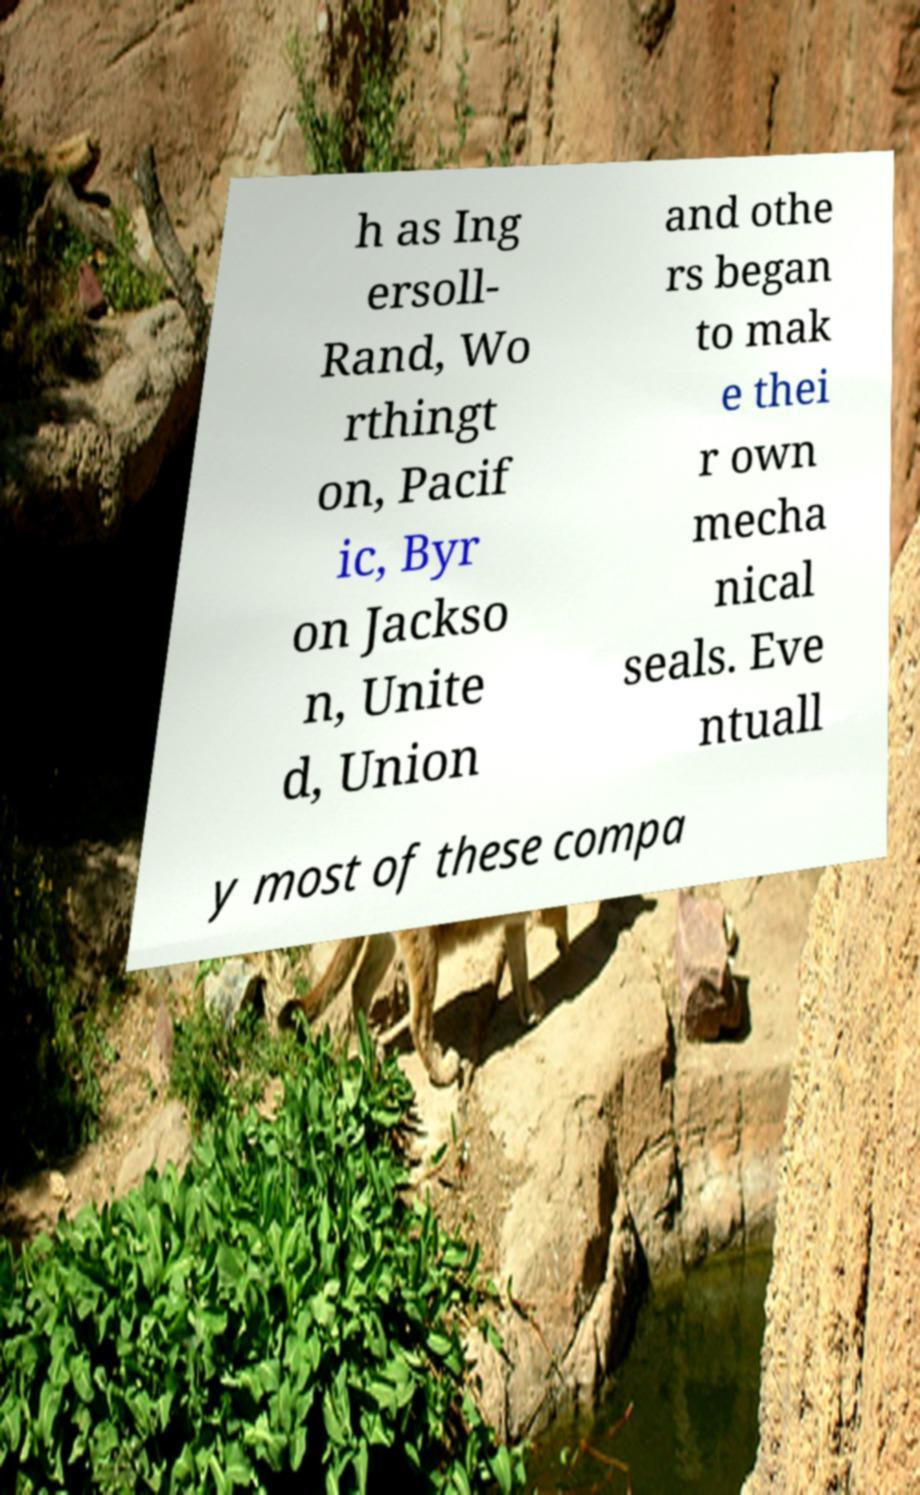Please identify and transcribe the text found in this image. h as Ing ersoll- Rand, Wo rthingt on, Pacif ic, Byr on Jackso n, Unite d, Union and othe rs began to mak e thei r own mecha nical seals. Eve ntuall y most of these compa 